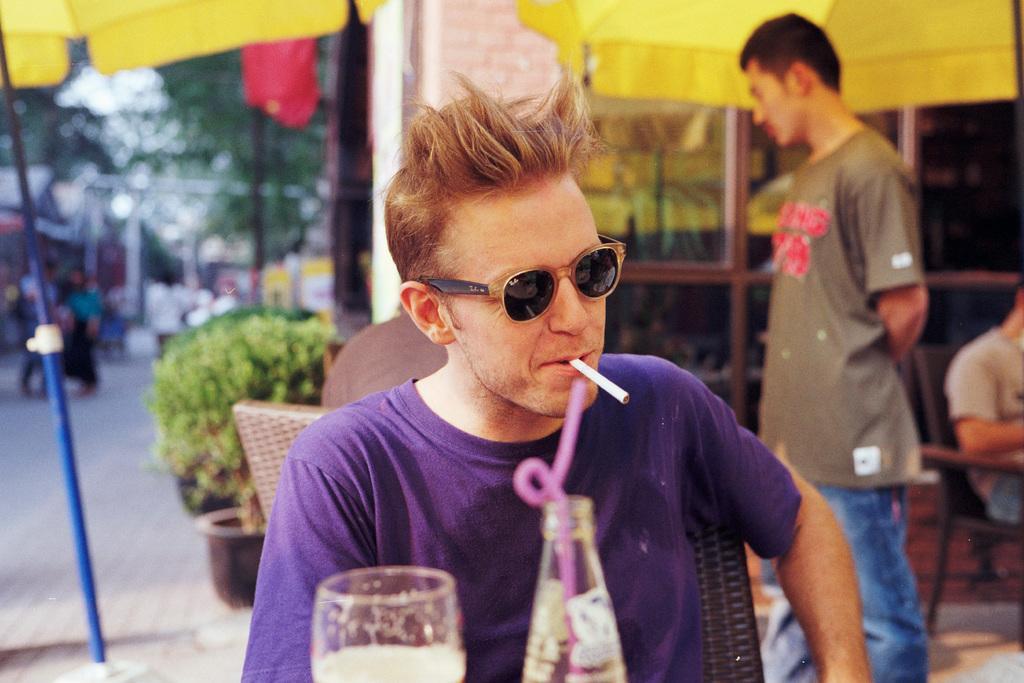Could you give a brief overview of what you see in this image? In this picture I can observe a man sitting in the chair, wearing violet color T shirt. He is holding a cigarette in his mouth. The man is wearing spectacles. In front of him there is a glass and a bottle. On the right side there is another person standing. I can observe yellow color umbrellas on the top of the picture. In the background there are trees and plants. 